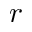Convert formula to latex. <formula><loc_0><loc_0><loc_500><loc_500>r</formula> 